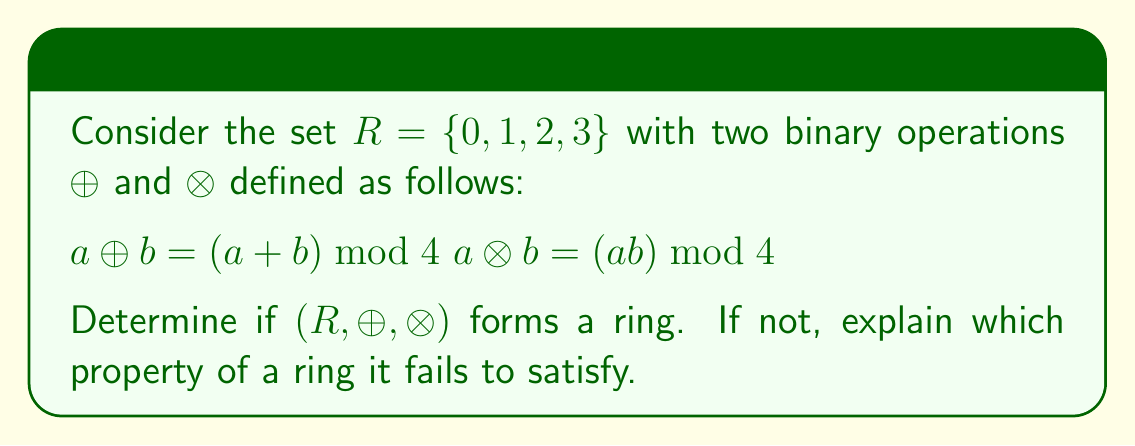Teach me how to tackle this problem. To determine if $(R, \oplus, \otimes)$ forms a ring, we need to check if it satisfies all the ring axioms:

1. $(R, \oplus)$ is an abelian group:
   a) Closure: $\forall a, b \in R, a \oplus b \in R$ (satisfied by definition)
   b) Associativity: $\forall a, b, c \in R, (a \oplus b) \oplus c = a \oplus (b \oplus c)$ (satisfied)
   c) Identity: $0$ is the identity element for $\oplus$
   d) Inverse: Each element has an additive inverse (e.g., $1 \oplus 3 = 0$)
   e) Commutativity: $\forall a, b \in R, a \oplus b = b \oplus a$ (satisfied)

2. $(R, \otimes)$ is a monoid:
   a) Closure: $\forall a, b \in R, a \otimes b \in R$ (satisfied by definition)
   b) Associativity: $\forall a, b, c \in R, (a \otimes b) \otimes c = a \otimes (b \otimes c)$ (satisfied)
   c) Identity: $1$ is the identity element for $\otimes$

3. Distributivity:
   $\forall a, b, c \in R, a \otimes (b \oplus c) = (a \otimes b) \oplus (a \otimes c)$
   $(a \oplus b) \otimes c = (a \otimes c) \oplus (b \otimes c)$

Let's check the left distributive property:

$2 \otimes (1 \oplus 3) = 2 \otimes 0 = 0$
$(2 \otimes 1) \oplus (2 \otimes 3) = 2 \oplus 2 = 0$

The left distributive property holds. Similarly, we can verify that the right distributive property holds as well.

All ring axioms are satisfied, so $(R, \oplus, \otimes)$ forms a ring.
Answer: Yes, $(R, \oplus, \otimes)$ forms a ring. 